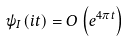<formula> <loc_0><loc_0><loc_500><loc_500>\psi _ { I } ( i t ) = O \left ( e ^ { 4 \pi t } \right )</formula> 